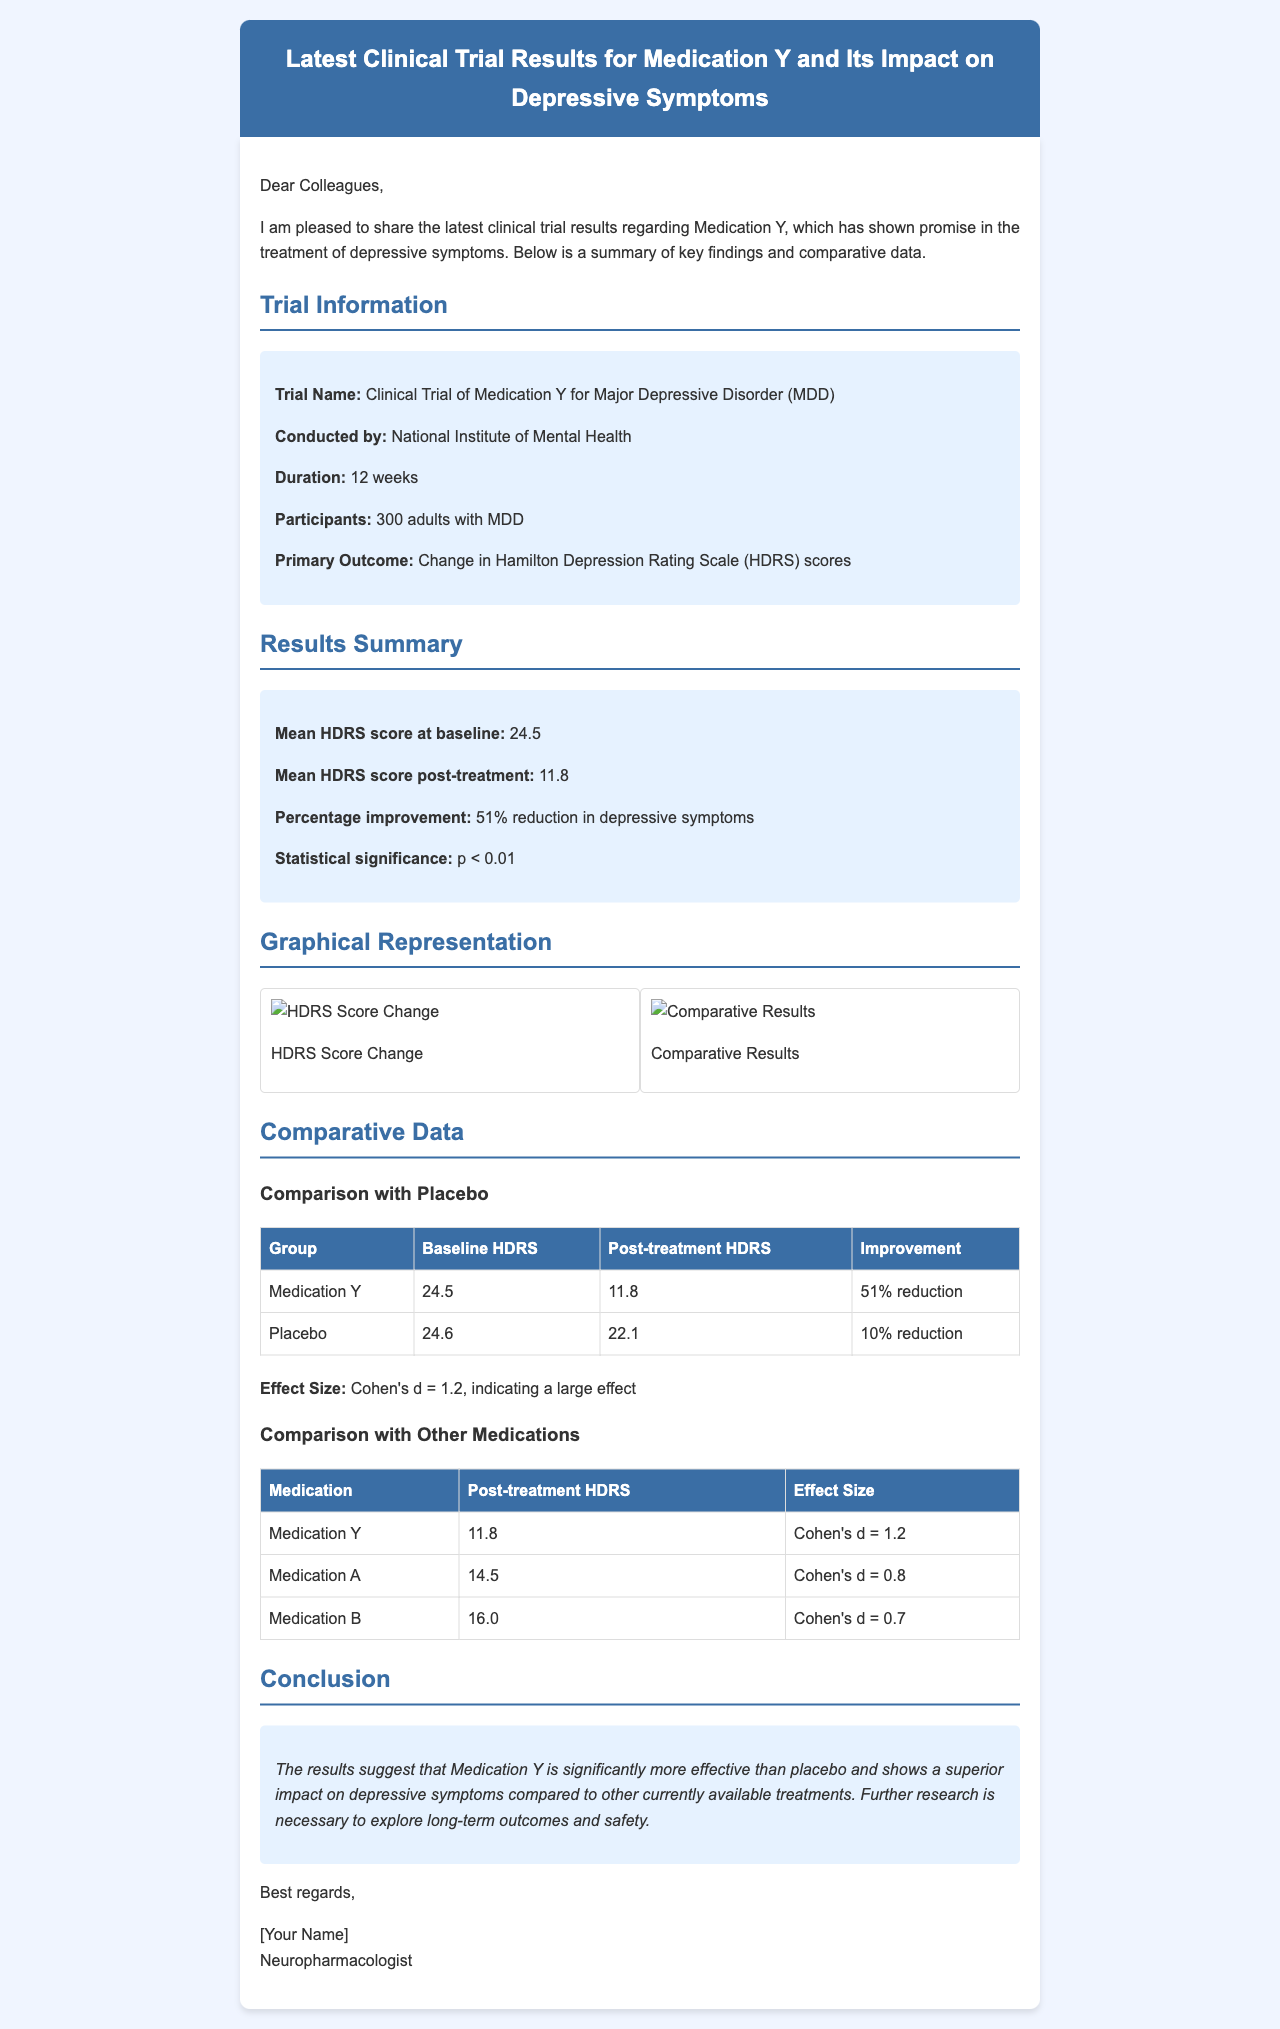What is the trial name? The trial name is located in the "Trial Information" section and specifies the study of Medication Y.
Answer: Clinical Trial of Medication Y for Major Depressive Disorder (MDD) What is the mean HDRS score post-treatment? The mean HDRS score post-treatment is found in the "Results Summary" section, where it details significant improvements.
Answer: 11.8 What is the duration of the trial? The duration is mentioned in the "Trial Information" section, indicating how long the study was conducted.
Answer: 12 weeks What percentage of improvement was observed with Medication Y? The percentage of improvement is outlined in the "Results Summary" section, showing the effectiveness of the medication.
Answer: 51% reduction Which group showed a 10% reduction in depressive symptoms? This information can be found in the "Comparative Data" section under the "Comparison with Placebo" table, comparing the results of different groups.
Answer: Placebo What is the effect size (Cohen's d) for Medication Y? The effect size is mentioned in the "Comparative Data" section and provides a measure of the treatment's effectiveness.
Answer: Cohen's d = 1.2 Which medication showed a post-treatment HDRS of 14.5? This question relates to the "Comparison with Other Medications" table and identifies a specific medication's outcome.
Answer: Medication A What is the statistical significance of the trial results? The statistical significance can be found in the "Results Summary" and is an important measure of the validity of the findings.
Answer: p < 0.01 What organization conducted the trial? The conducting organization is specified in the "Trial Information" section, indicating the authority behind the research.
Answer: National Institute of Mental Health 